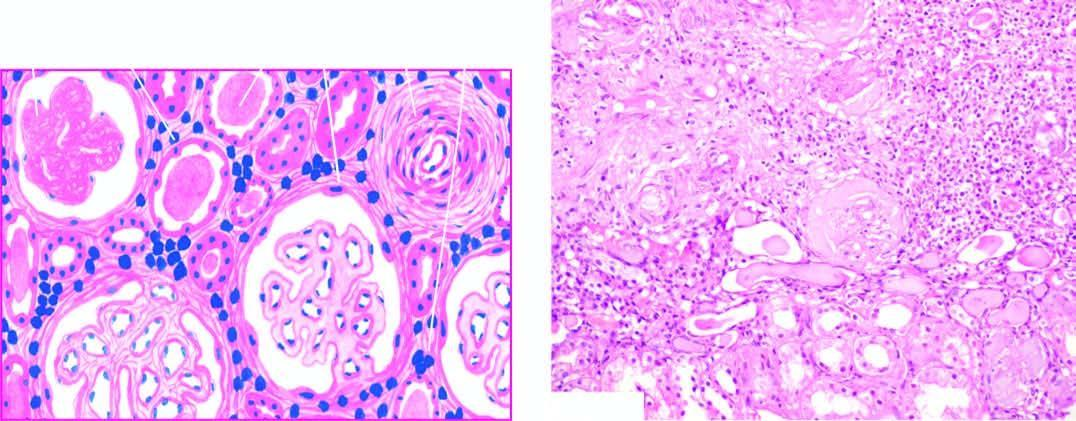re the capillary walls surrounded by abundant fibrous tissue and chronic interstitial inflammatory reaction?
Answer the question using a single word or phrase. No 